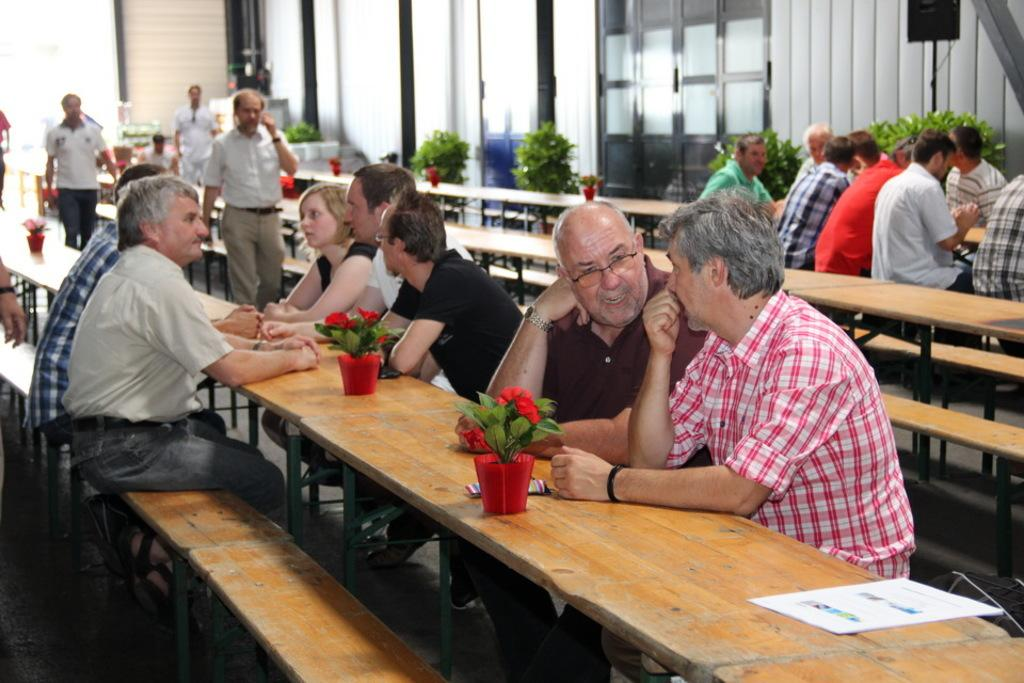How many people are in the image? There is a group of people in the image. What are the people doing in the image? The people are sitting around a table. What can be seen around the table besides the people? There are flower pots around the table. What is the main architectural feature in the image? There is a glass door at the center of the image. What type of business is being conducted in the image? There is no indication of a business being conducted in the image; it simply shows a group of people sitting around a table. How many boats can be seen in the image? There are no boats present in the image. 